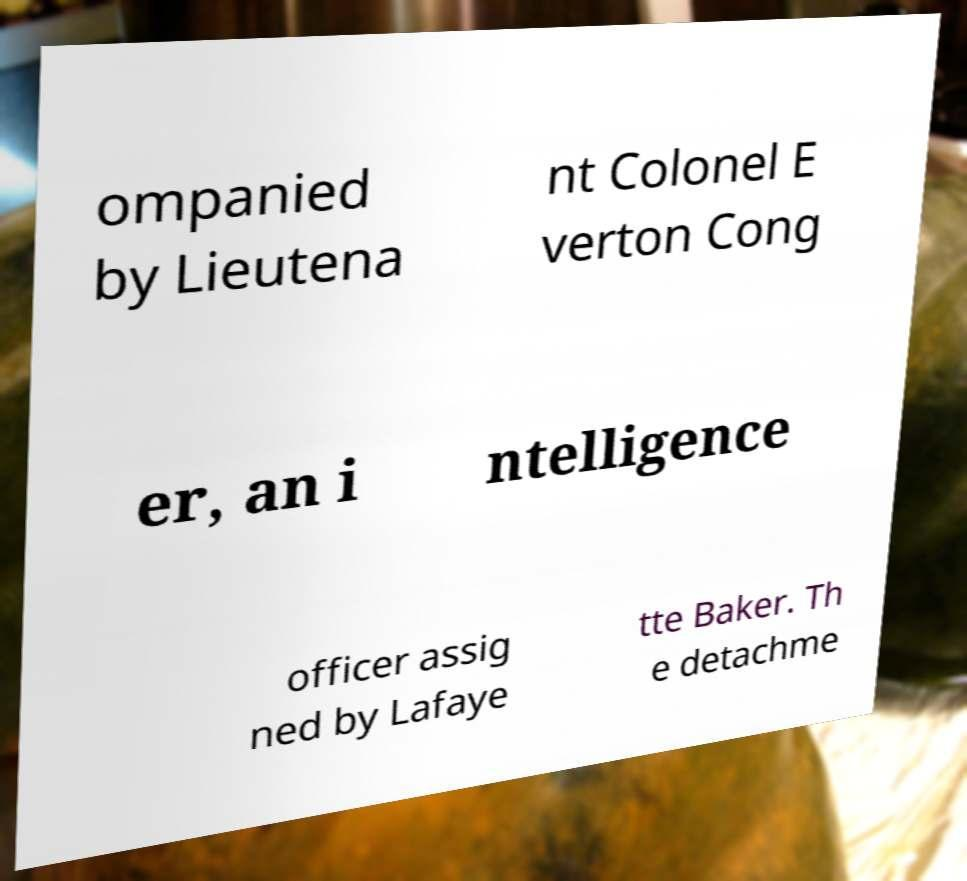Can you accurately transcribe the text from the provided image for me? ompanied by Lieutena nt Colonel E verton Cong er, an i ntelligence officer assig ned by Lafaye tte Baker. Th e detachme 